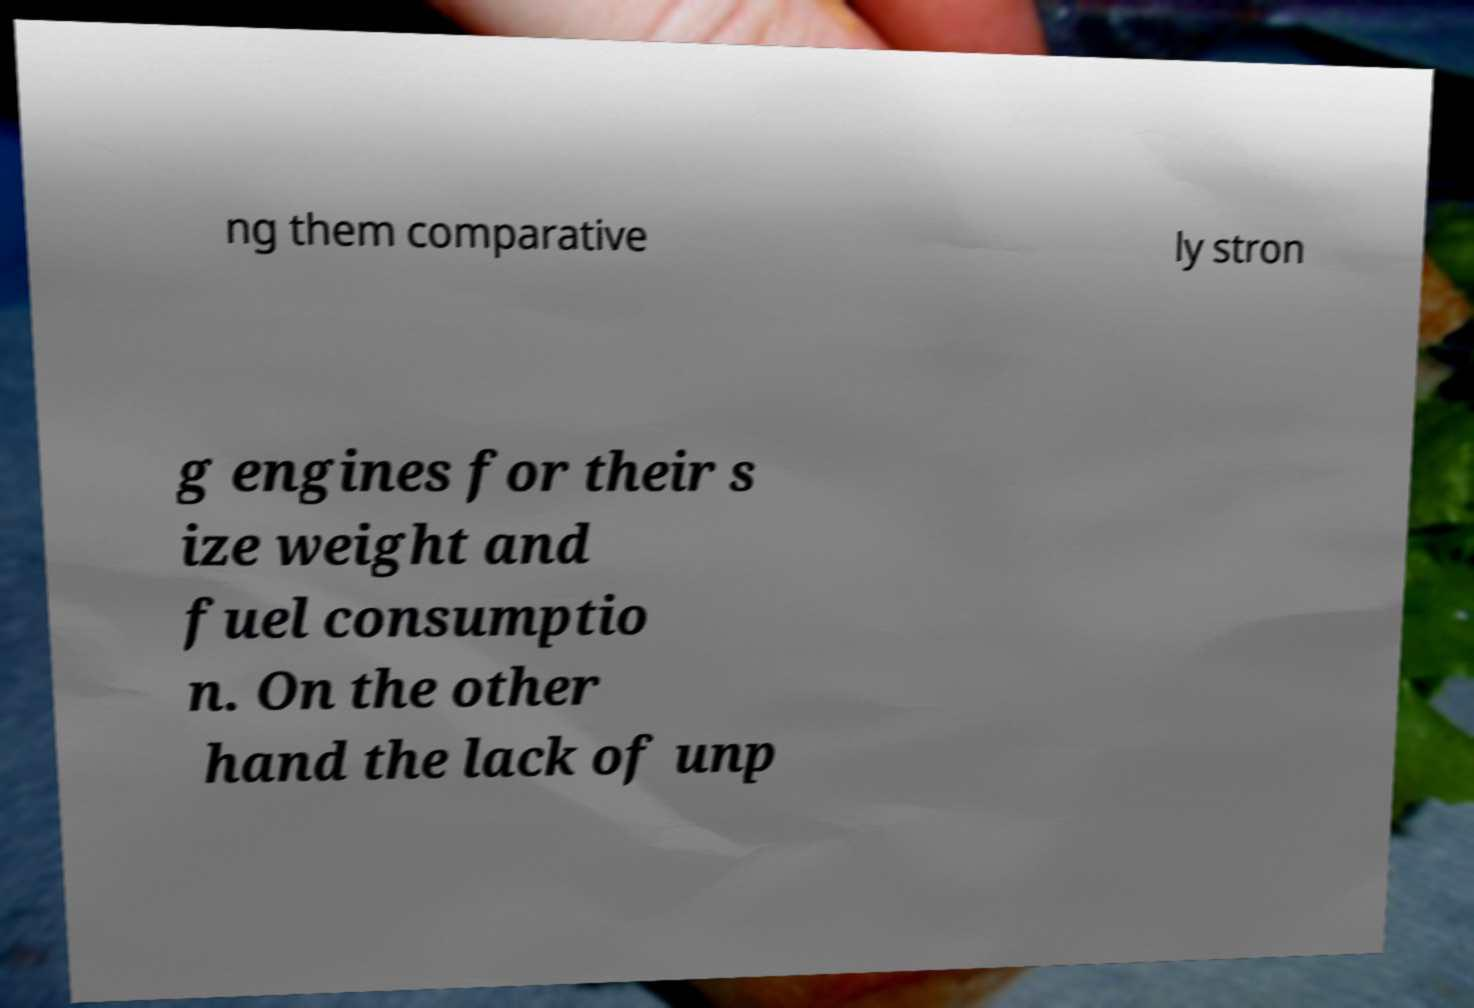Please identify and transcribe the text found in this image. ng them comparative ly stron g engines for their s ize weight and fuel consumptio n. On the other hand the lack of unp 